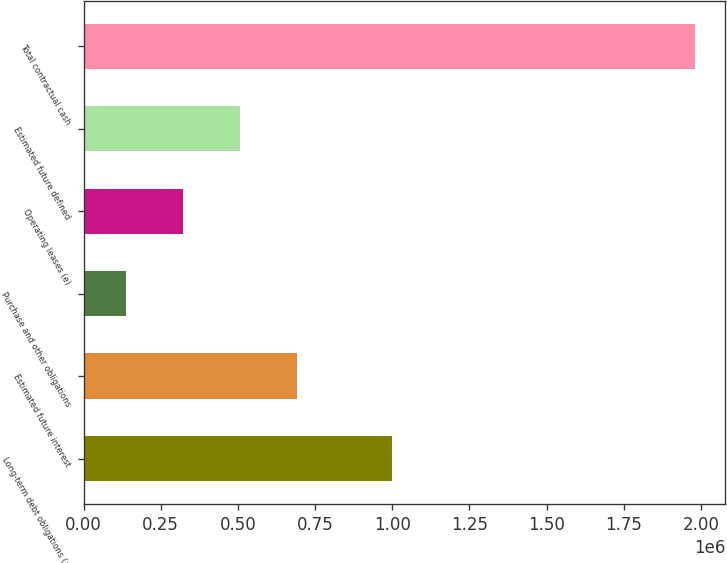<chart> <loc_0><loc_0><loc_500><loc_500><bar_chart><fcel>Long-term debt obligations (a)<fcel>Estimated future interest<fcel>Purchase and other obligations<fcel>Operating leases (e)<fcel>Estimated future defined<fcel>Total contractual cash<nl><fcel>999369<fcel>689895<fcel>136843<fcel>321194<fcel>505545<fcel>1.98035e+06<nl></chart> 